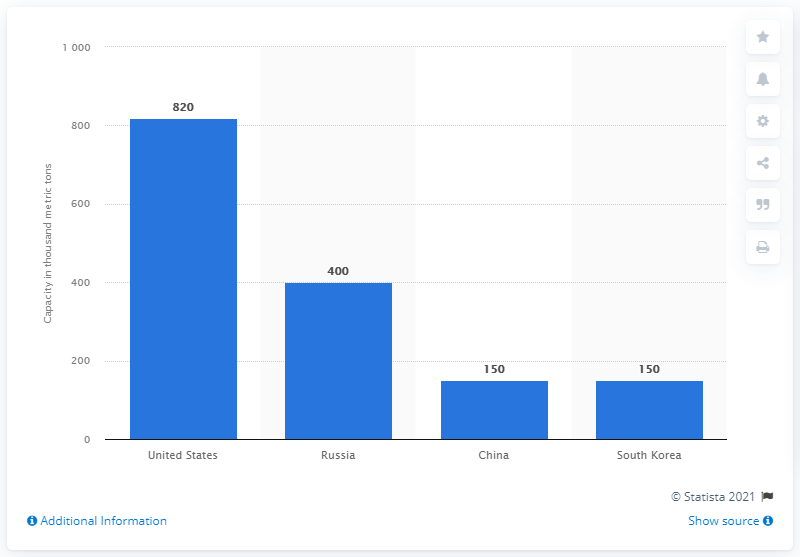Outline some significant characteristics in this image. It is expected that Russia will have 400,000 metric tons of new production capacity between 2019 and 2021. The United States has the largest new production capacity of low-density polyethylene. 